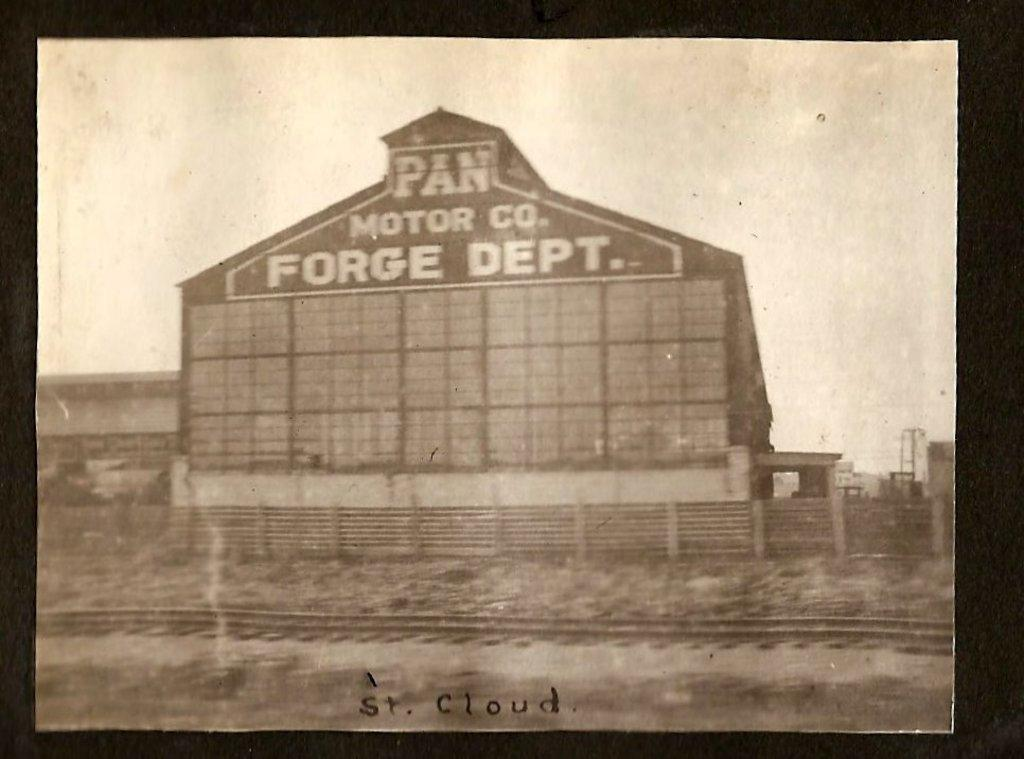What is the main subject of the image? The main subject of the image is a photo of a building with a name. What can be seen near the building in the image? There is a railway track near the building in the image. What is visible in the background of the image? The sky is visible in the background of the image. How many snakes are slithering on the railway track in the image? There are no snakes present in the image; it features a photo of a building with a railway track nearby. What type of knee injury can be seen in the image? There is no knee injury visible in the image; it is a photo of a building with a railway track nearby. 